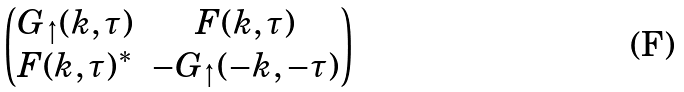<formula> <loc_0><loc_0><loc_500><loc_500>\begin{pmatrix} G _ { \uparrow } ( k , \tau ) & F ( k , \tau ) \\ F ( k , \tau ) ^ { * } & - G _ { \uparrow } ( - k , - \tau ) \end{pmatrix}</formula> 